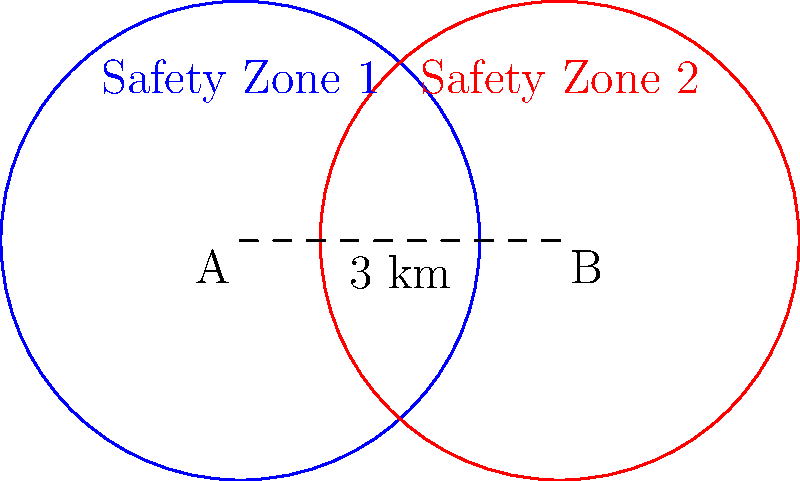Two nuclear power plants, A and B, are located 4 km apart. Each plant has a circular safety zone with a radius of 3 km. Calculate the area of the overlapping region between the two safety zones, rounded to the nearest square kilometer. This information is crucial for determining the efficiency of our safety protocols and optimizing emergency response plans. To calculate the area of the overlapping region, we'll use the formula for the area of intersection of two circles:

1) First, calculate the distance between the centers (d):
   $d = 4$ km

2) The radius of each circle (r) is 3 km.

3) Use the formula for the area of intersection:
   $A = 2r^2 \arccos(\frac{d}{2r}) - d\sqrt{r^2 - (\frac{d}{2})^2}$

4) Substitute the values:
   $A = 2(3^2) \arccos(\frac{4}{2(3)}) - 4\sqrt{3^2 - (\frac{4}{2})^2}$

5) Simplify:
   $A = 18 \arccos(\frac{2}{3}) - 4\sqrt{9 - 4}$
   $A = 18 \arccos(\frac{2}{3}) - 4\sqrt{5}$

6) Calculate:
   $A \approx 18(0.8411) - 4(2.2361)$
   $A \approx 15.1398 - 8.9444$
   $A \approx 6.1954$ km²

7) Rounding to the nearest square kilometer:
   $A \approx 6$ km²

This overlapping area represents the region where safety protocols from both plants must be coordinated for maximum efficiency.
Answer: 6 km² 